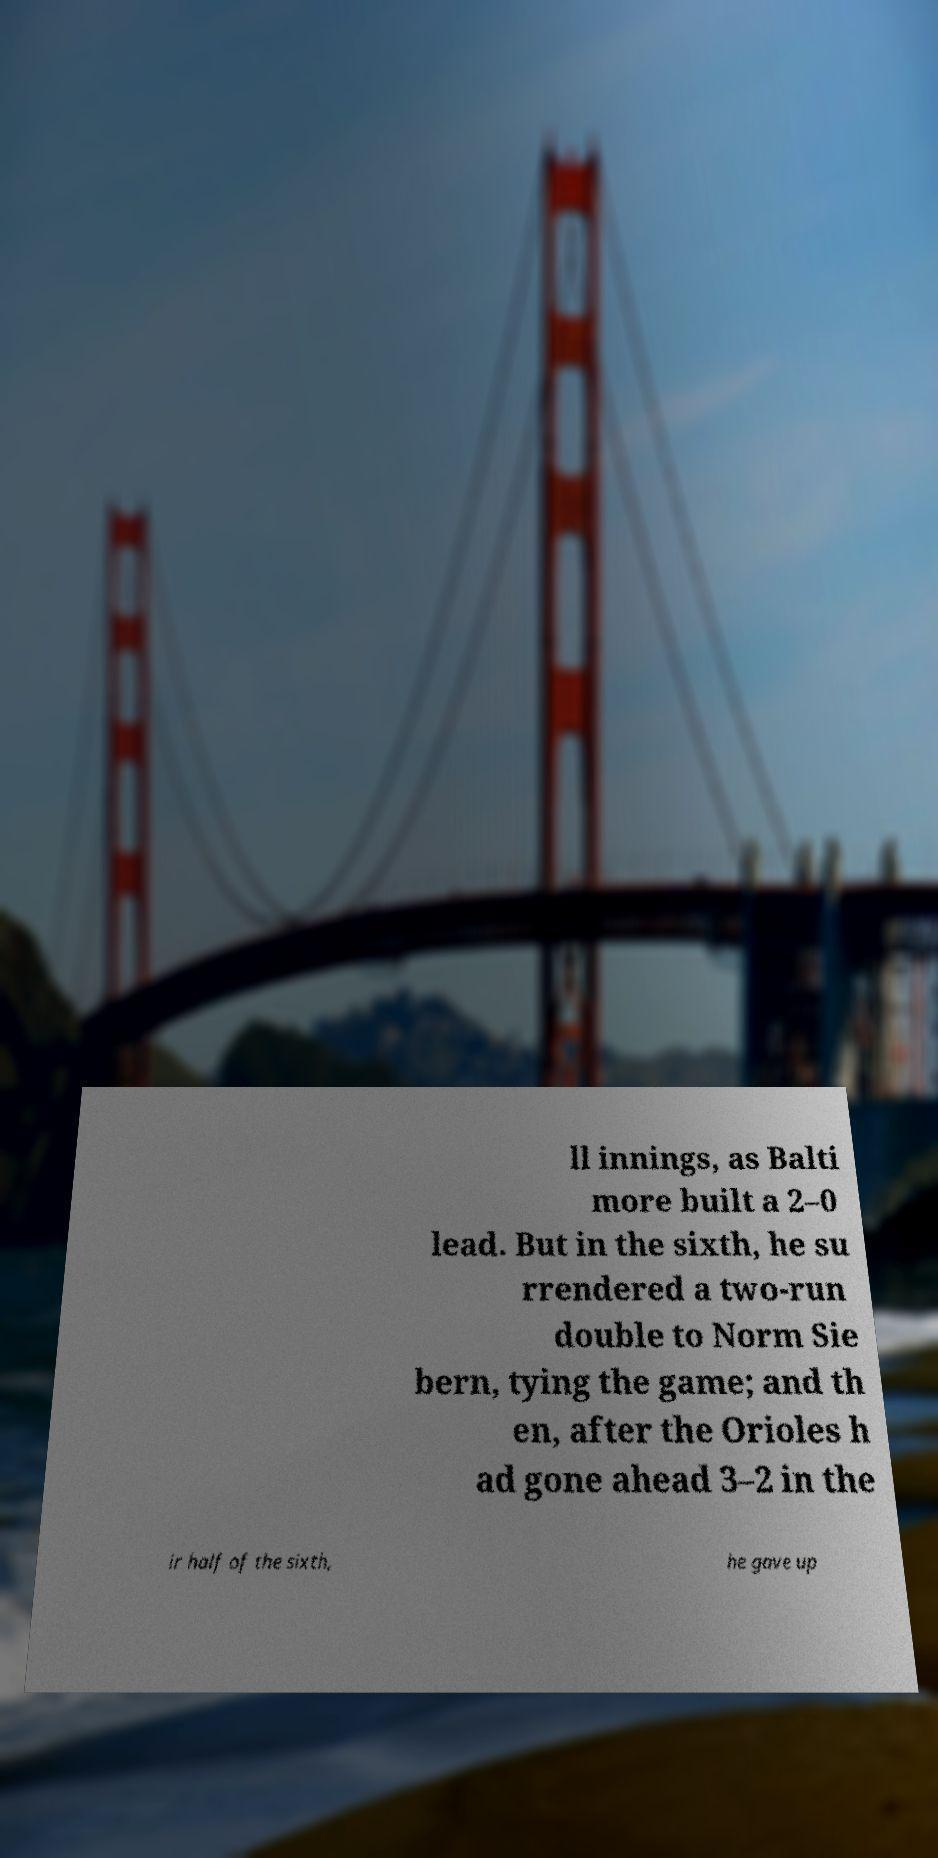Can you read and provide the text displayed in the image?This photo seems to have some interesting text. Can you extract and type it out for me? ll innings, as Balti more built a 2–0 lead. But in the sixth, he su rrendered a two-run double to Norm Sie bern, tying the game; and th en, after the Orioles h ad gone ahead 3–2 in the ir half of the sixth, he gave up 